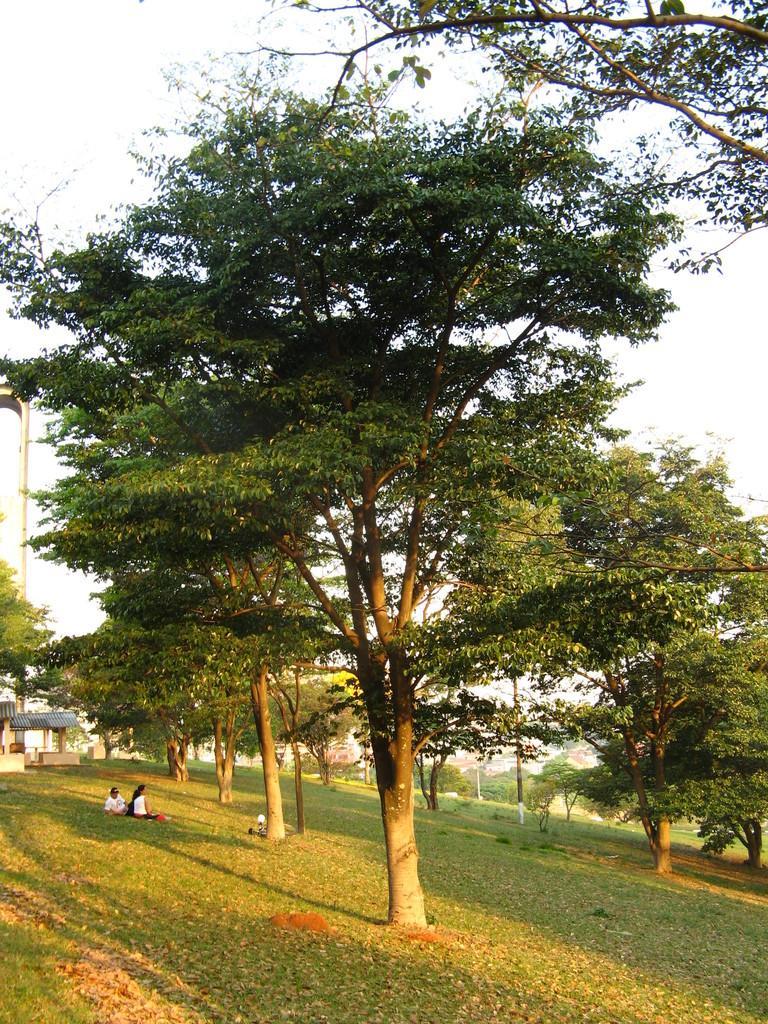Can you describe this image briefly? In this image there are trees and we can see people sitting. On the left there is a shed. In the background there is sky and we can see a pole. 